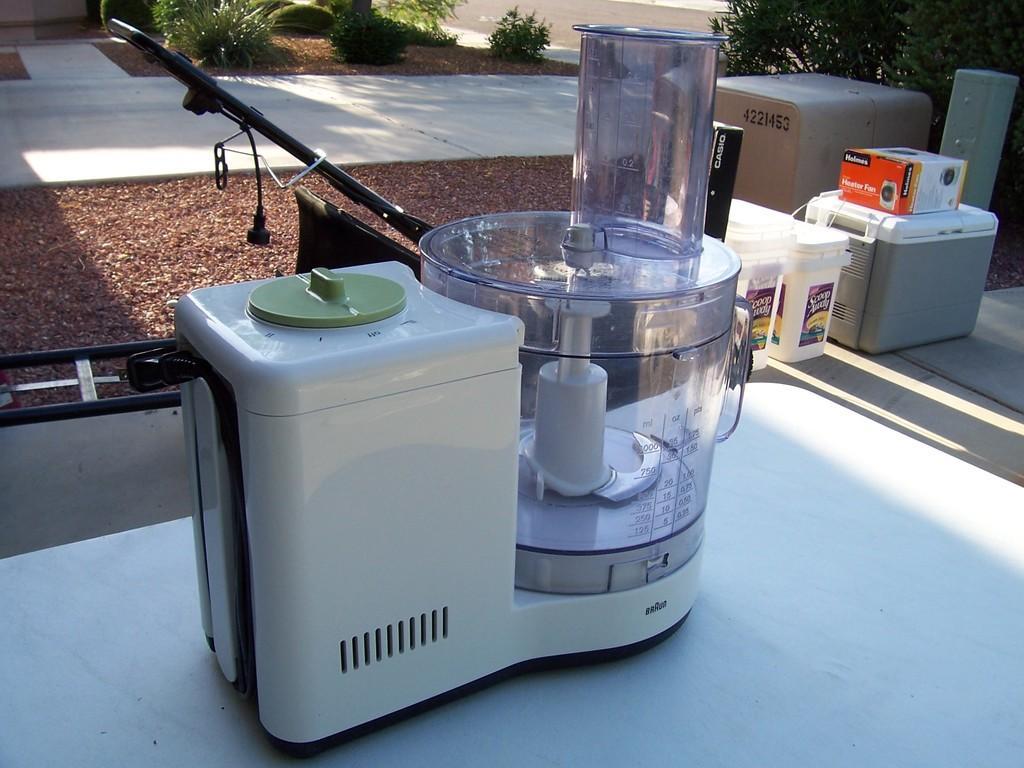Describe this image in one or two sentences. This is a mixture, these are containers and trees. 